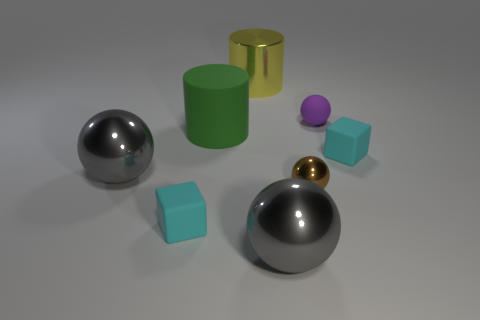What size is the metallic object behind the small purple matte ball right of the tiny brown ball?
Give a very brief answer. Large. Are there the same number of metal objects that are on the left side of the large metallic cylinder and cyan blocks?
Make the answer very short. No. What number of other things are the same color as the small metal thing?
Your response must be concise. 0. Is the number of gray spheres to the right of the tiny purple matte sphere less than the number of purple things?
Make the answer very short. Yes. Are there any gray metallic balls that have the same size as the brown shiny object?
Your answer should be compact. No. What number of metallic balls are behind the tiny brown sphere that is in front of the small purple ball?
Your answer should be compact. 1. There is a small rubber cube that is to the right of the tiny matte object that is behind the large green matte cylinder; what is its color?
Your response must be concise. Cyan. The ball that is behind the brown metallic ball and left of the purple matte ball is made of what material?
Keep it short and to the point. Metal. Is there a cyan metal thing of the same shape as the brown thing?
Provide a short and direct response. No. There is a big green object that is left of the large yellow cylinder; does it have the same shape as the yellow thing?
Make the answer very short. Yes. 